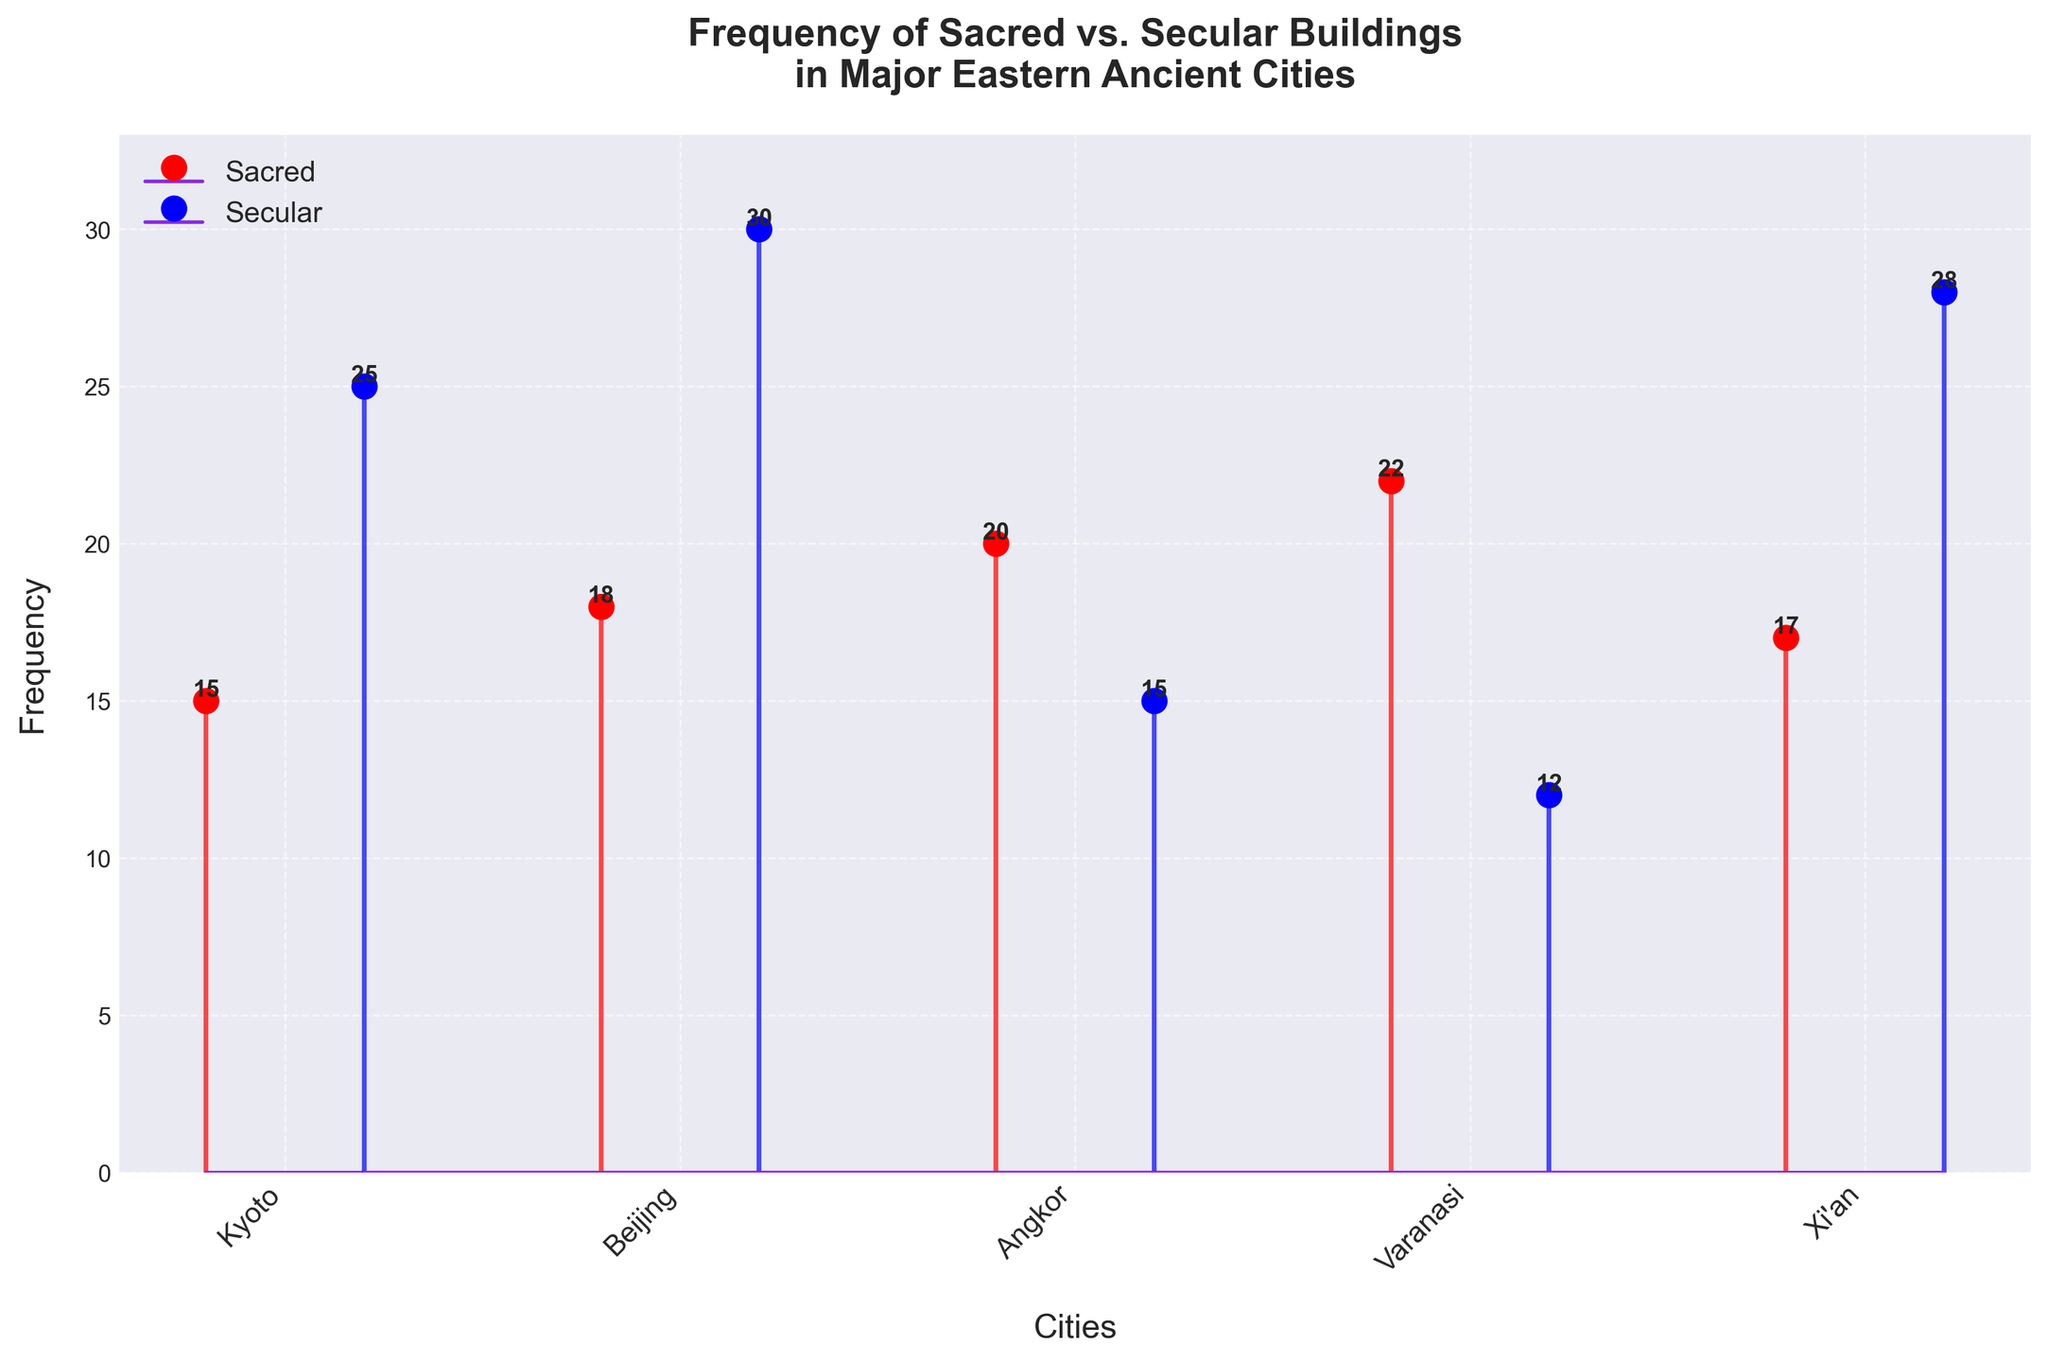What are the colors used to represent sacred and secular buildings? The plot uses red markers and lines to represent sacred buildings and blue markers and lines to represent secular buildings. This can be seen from the colors of the markers and the legend.
Answer: Red for sacred, blue for secular What is the title of the figure? The title is typically located at the top center of the plot and describes the overall topic being visualized.
Answer: Frequency of Sacred vs. Secular Buildings in Major Eastern Ancient Cities Which city has the highest frequency of sacred buildings? By looking at the red markers or lines representing sacred buildings, the city with the highest value will be the one with the highest marker.
Answer: Varanasi How many sacred buildings are there in Angkor? Look for the red marker or line that corresponds to Angkor and read the value next to it.
Answer: 20 Which city has more secular buildings, Xi'an or Kyoto? Compare the blue markers or lines that represent secular buildings in Xi'an and Kyoto. The city with the higher value has more secular buildings.
Answer: Beijing What is the sum of frequencies of sacred buildings in all cities? Sum the frequencies of sacred buildings across all cities: 15 (Kyoto) + 18 (Beijing) + 20 (Angkor) + 22 (Varanasi) + 17 (Xi'an).
Answer: 92 What is the difference in frequency between sacred and secular buildings in Beijing? Subtract the frequency of sacred buildings from the frequency of secular buildings in Beijing: 30 (sec) - 18 (sac).
Answer: 12 Which city has the smallest total number of buildings (both sacred and secular)? For each city, add the frequencies of sacred and secular buildings and then identify the city with the smallest total: Kyoto (40), Beijing (48), Angkor (35), Varanasi (34), Xi'an (45).
Answer: Varanasi What is the average frequency of secular buildings across all cities? Calculate the sum of frequencies of secular buildings and divide by the number of cities: (25 + 30 + 15 + 12 + 28) / 5.
Answer: 22 In which city is the frequency of secular buildings greater than the frequency of sacred buildings by more than 10? Check the difference between secular and sacred buildings for each city and identify where this difference is greater than 10: 25 - 15 (Kyoto), 30 - 18 (Beijing), 15 - 20 (Angkor), 12 - 22 (Varanasi), and 28 - 17 (Xi'an); only Beijing and Xi'an meet the criterion.
Answer: Beijing and Xi’an 